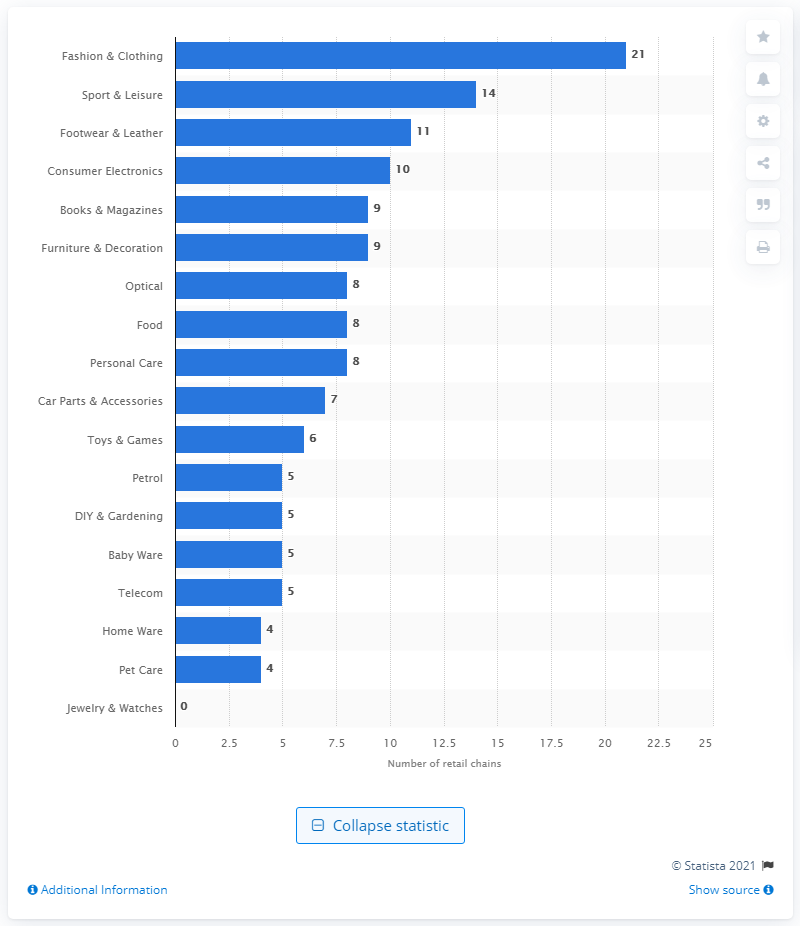Mention a couple of crucial points in this snapshot. In the year 2020, there were 11 retail chains in Slovenia. 